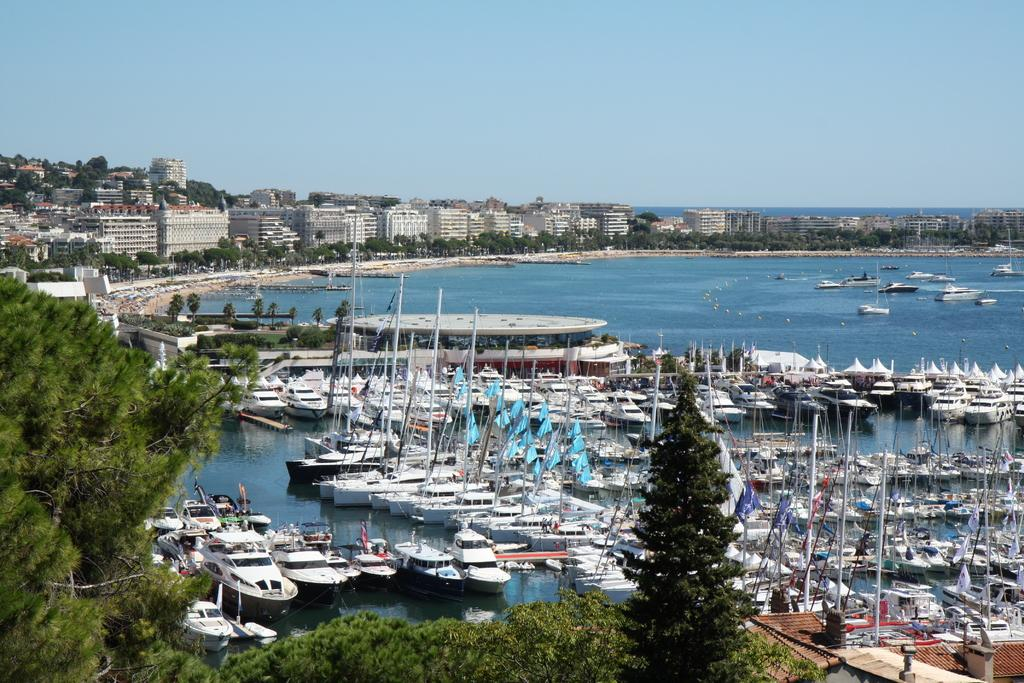What can be seen in the water in the middle of the image? There are boats in the water in the middle of the image. What type of natural scenery is visible in the background of the image? There are trees in the background of the image. What type of man-made structures can be seen in the background of the image? There are buildings in the background of the image. What is visible at the top of the image? The sky is visible at the top of the image. What is the tendency of the jail to float in the water in the image? There is no jail present in the image, so the question cannot be answered. 